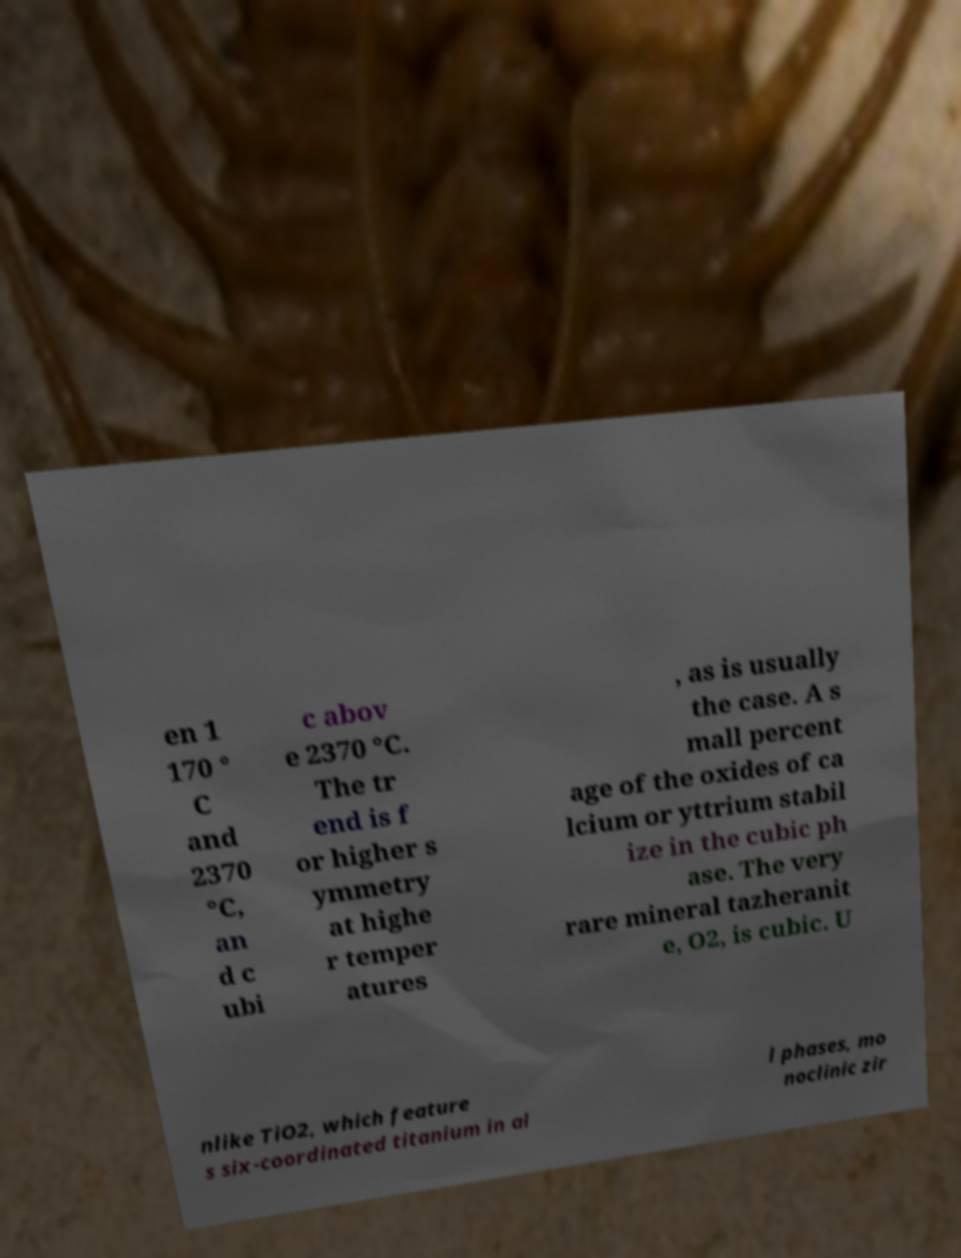For documentation purposes, I need the text within this image transcribed. Could you provide that? en 1 170 ° C and 2370 °C, an d c ubi c abov e 2370 °C. The tr end is f or higher s ymmetry at highe r temper atures , as is usually the case. A s mall percent age of the oxides of ca lcium or yttrium stabil ize in the cubic ph ase. The very rare mineral tazheranit e, O2, is cubic. U nlike TiO2, which feature s six-coordinated titanium in al l phases, mo noclinic zir 